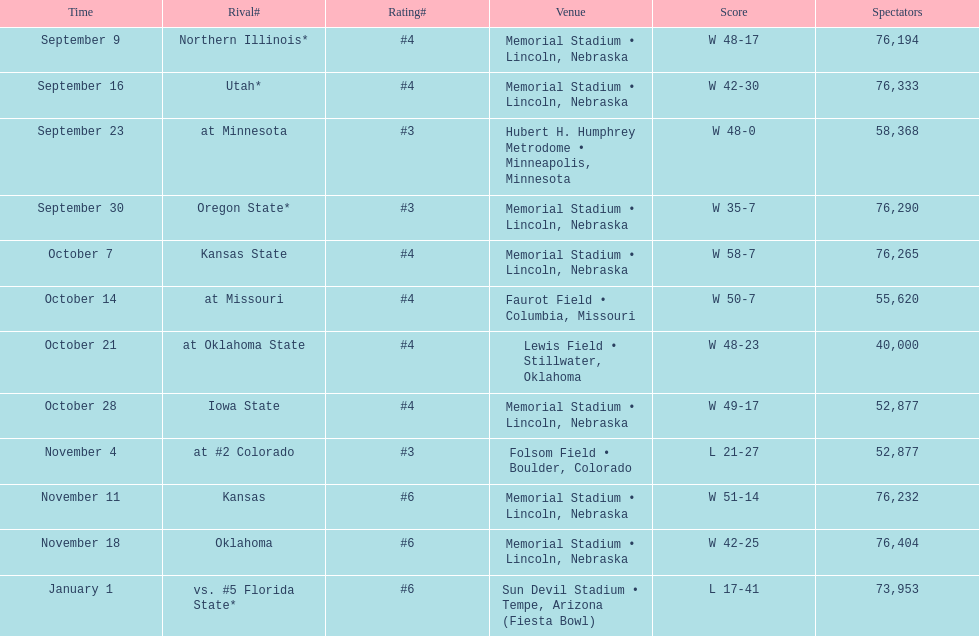What's the number of people who attended the oregon state game? 76,290. 